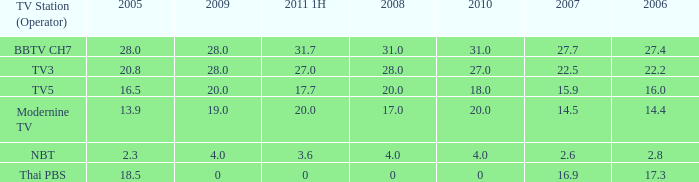What is the average 2007 value for a 2006 of 2.8 and 2009 under 20? 2.6. 